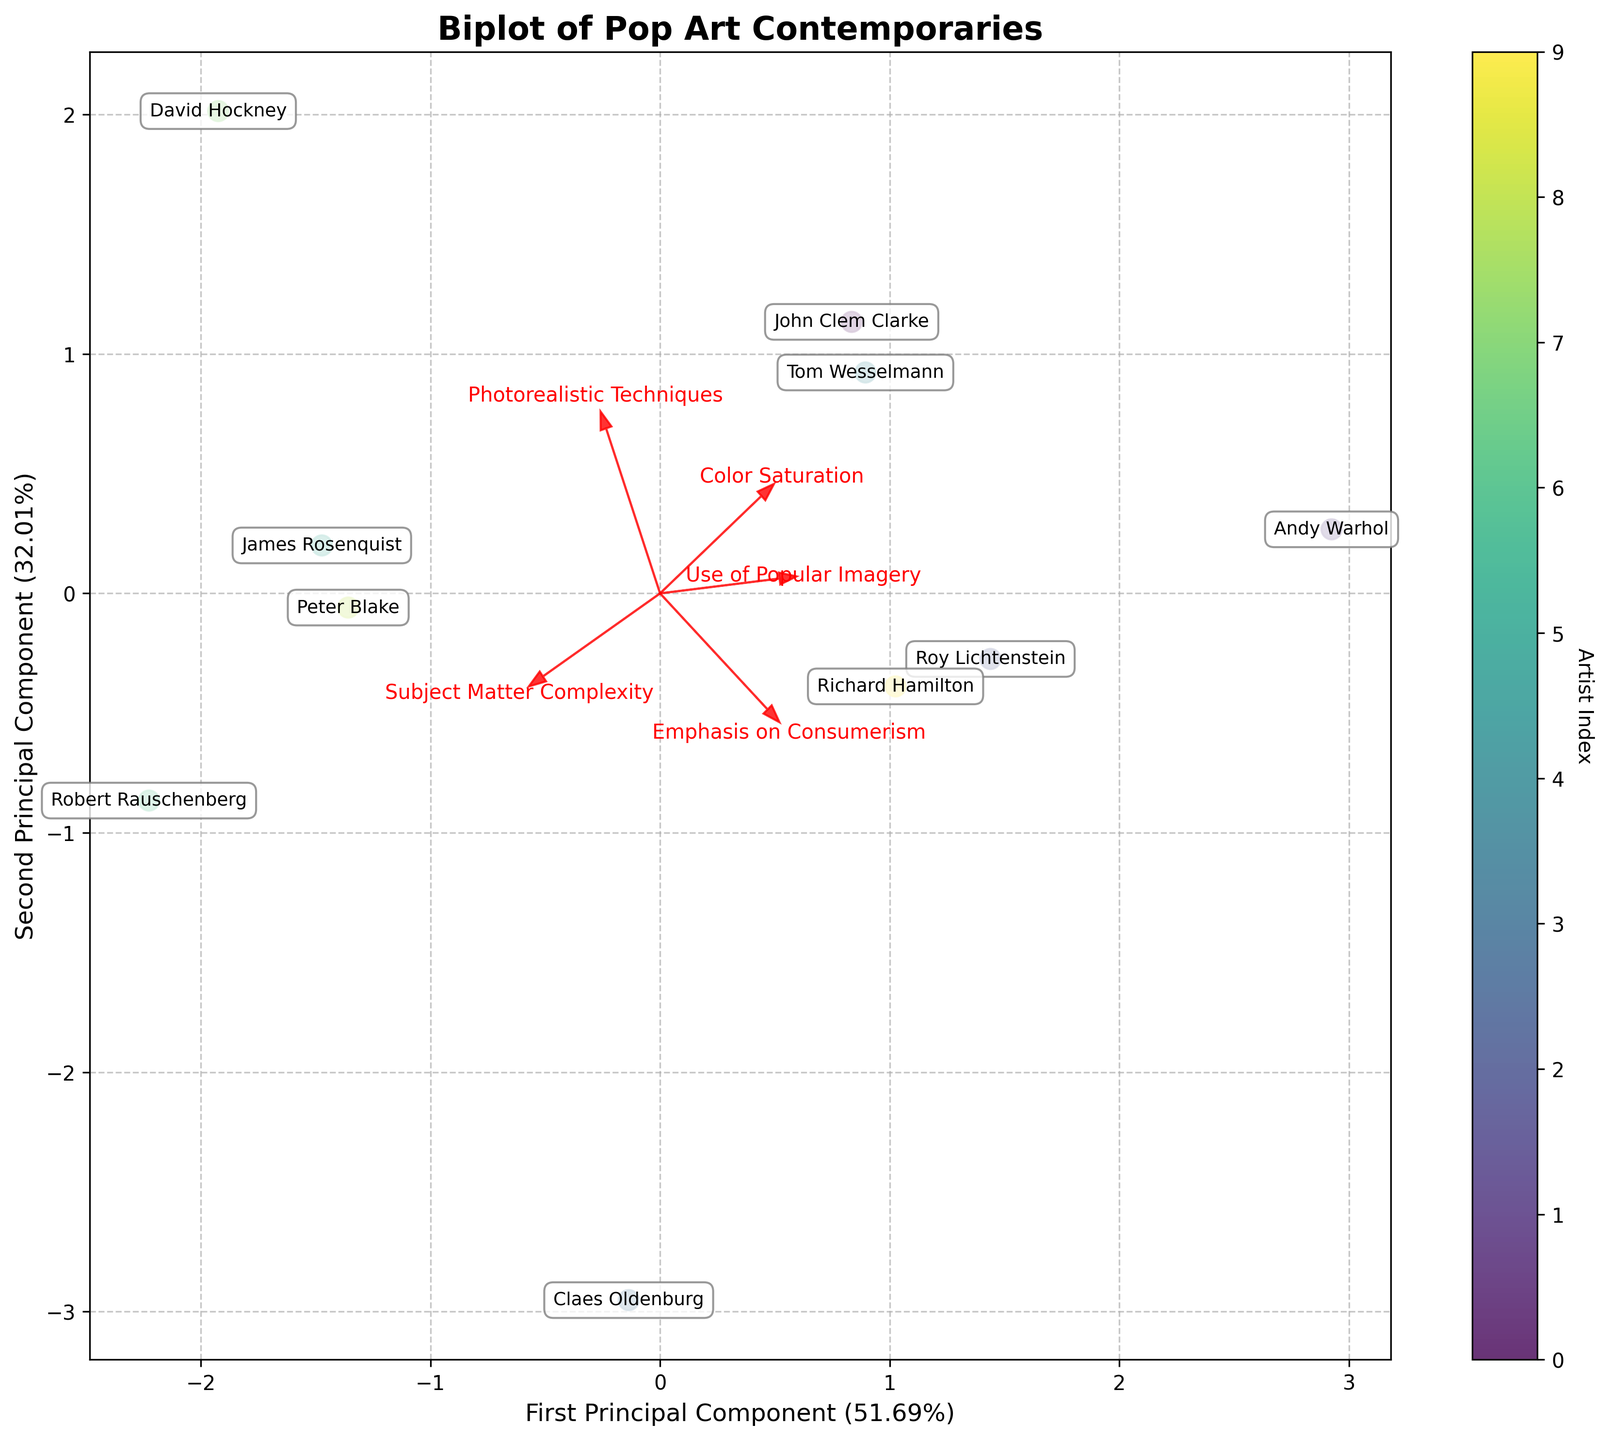What's the title of the figure? Find the text at the top center of the figure that describes its title.
Answer: Biplot of Pop Art Contemporaries How many artists are compared in the biplot? Count the number of unique annotated names in the plot.
Answer: 10 Which artist is positioned furthest to the right in the biplot? Look at the rightmost annotated name on the plot along the first principal component.
Answer: Roy Lichtenstein Which two artists have the closest positions on the biplot? Check for pair of artist names that are closest to each other visually on the plot.
Answer: John Clem Clarke and Tom Wesselmann What percentage of variation does the first principal component explain? Read the x-axis label to find the percentage explained by the first principal component.
Answer: 53.82% Which feature has the largest positive contribution to the first principal component? Look for the longest red arrow pointing right and note the feature it is labeled with.
Answer: Use of Popular Imagery Which artist has a larger value on the second principal component, Peter Blake or James Rosenquist? Compare the vertical positions (y-axis) of the two artists and note who is higher.
Answer: James Rosenquist Which feature is most negatively correlated with the first principal component? Identify the red arrow pointing closest to the leftmost and note the feature it is labeled with.
Answer: Emphasis on Consumerism Is John Clem Clarke more similar to Andy Warhol or Claes Oldenburg based on the biplot positions? Compare the distances between John Clem Clarke and the other two artists on the plot.
Answer: Andy Warhol Which principal component explains more of the variance, and by how much? Compare the percentages given in the x and y axis labels and calculate the difference.
Answer: First principal component by 26.55% 